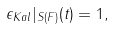Convert formula to latex. <formula><loc_0><loc_0><loc_500><loc_500>\epsilon _ { K a l } | _ { S ( F ) } ( t ) = 1 ,</formula> 